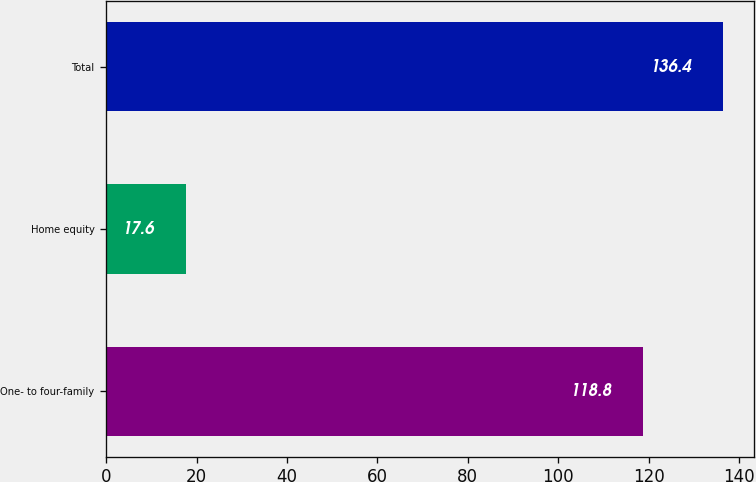Convert chart to OTSL. <chart><loc_0><loc_0><loc_500><loc_500><bar_chart><fcel>One- to four-family<fcel>Home equity<fcel>Total<nl><fcel>118.8<fcel>17.6<fcel>136.4<nl></chart> 